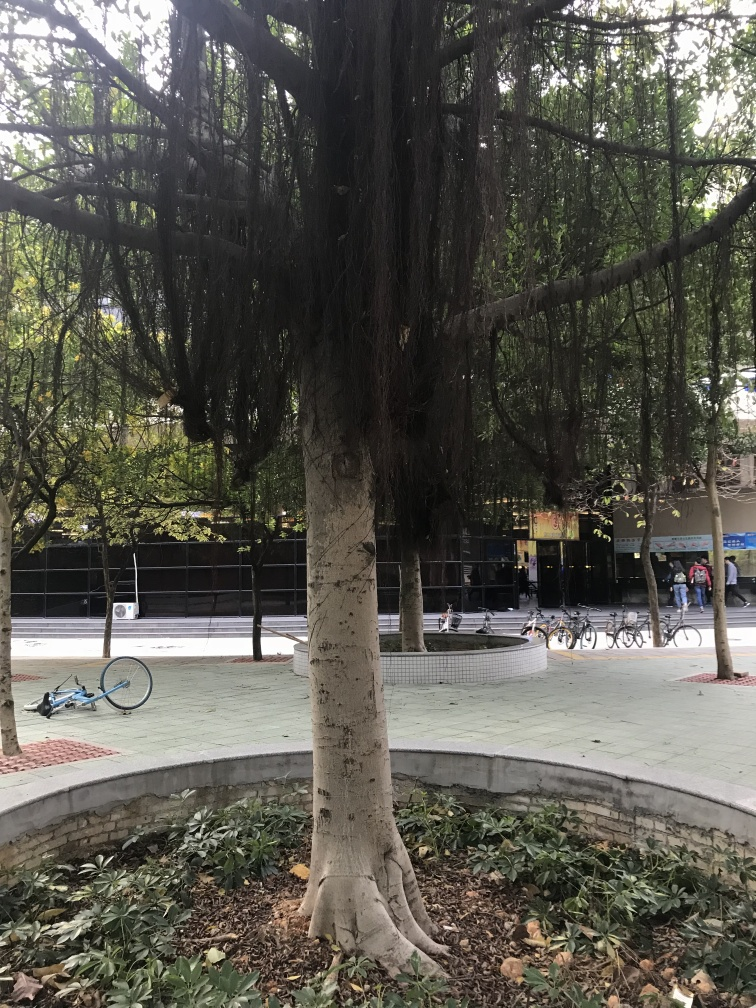What time of day does it seem to be and how can you tell? It appears to be daytime, likely in the late morning or early afternoon. This can be inferred from the amount of natural daylight in the scene and the shadows cast by the tree, which are present but not overly long or deep. The overall visibility of details in the shaded areas also indicates that the sun is fairly high in the sky. 